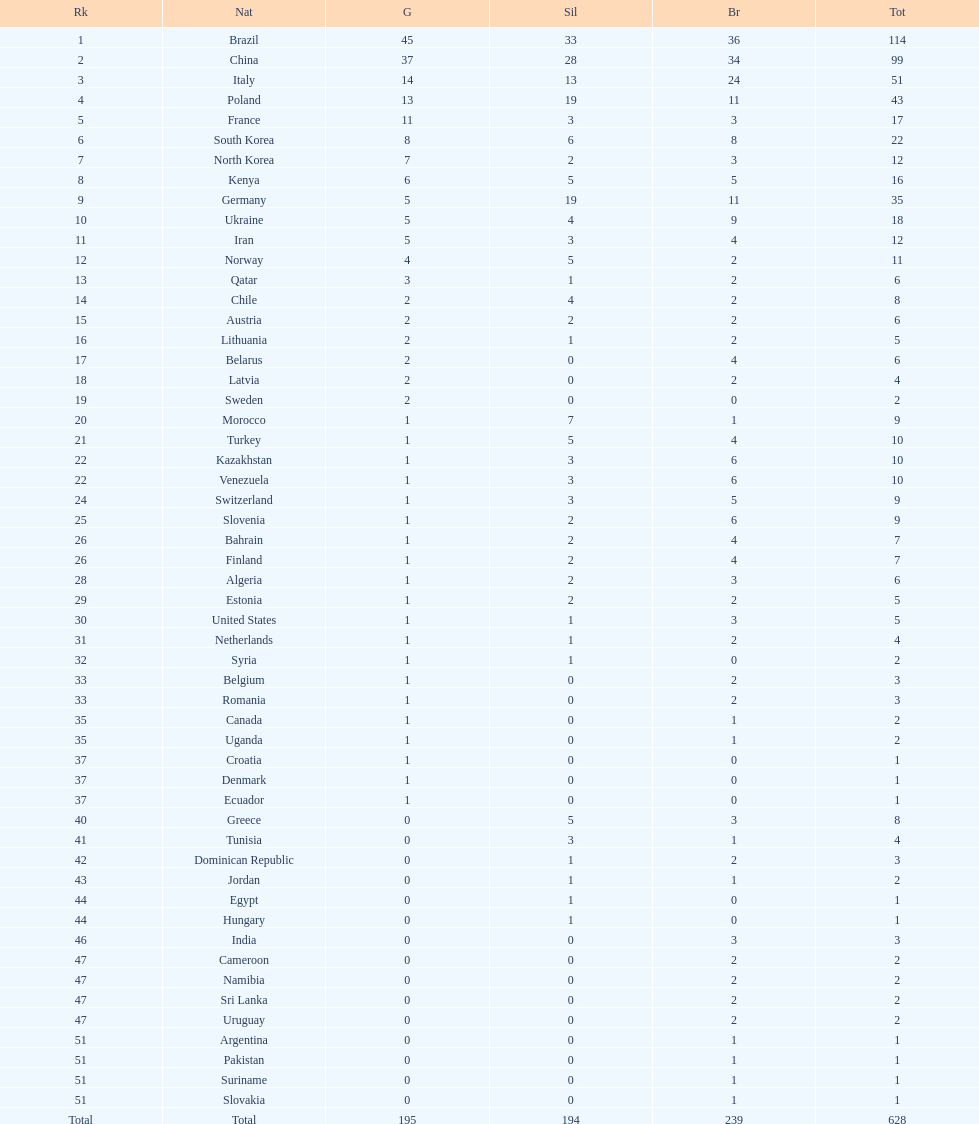How many gold medals did germany earn? 5. 